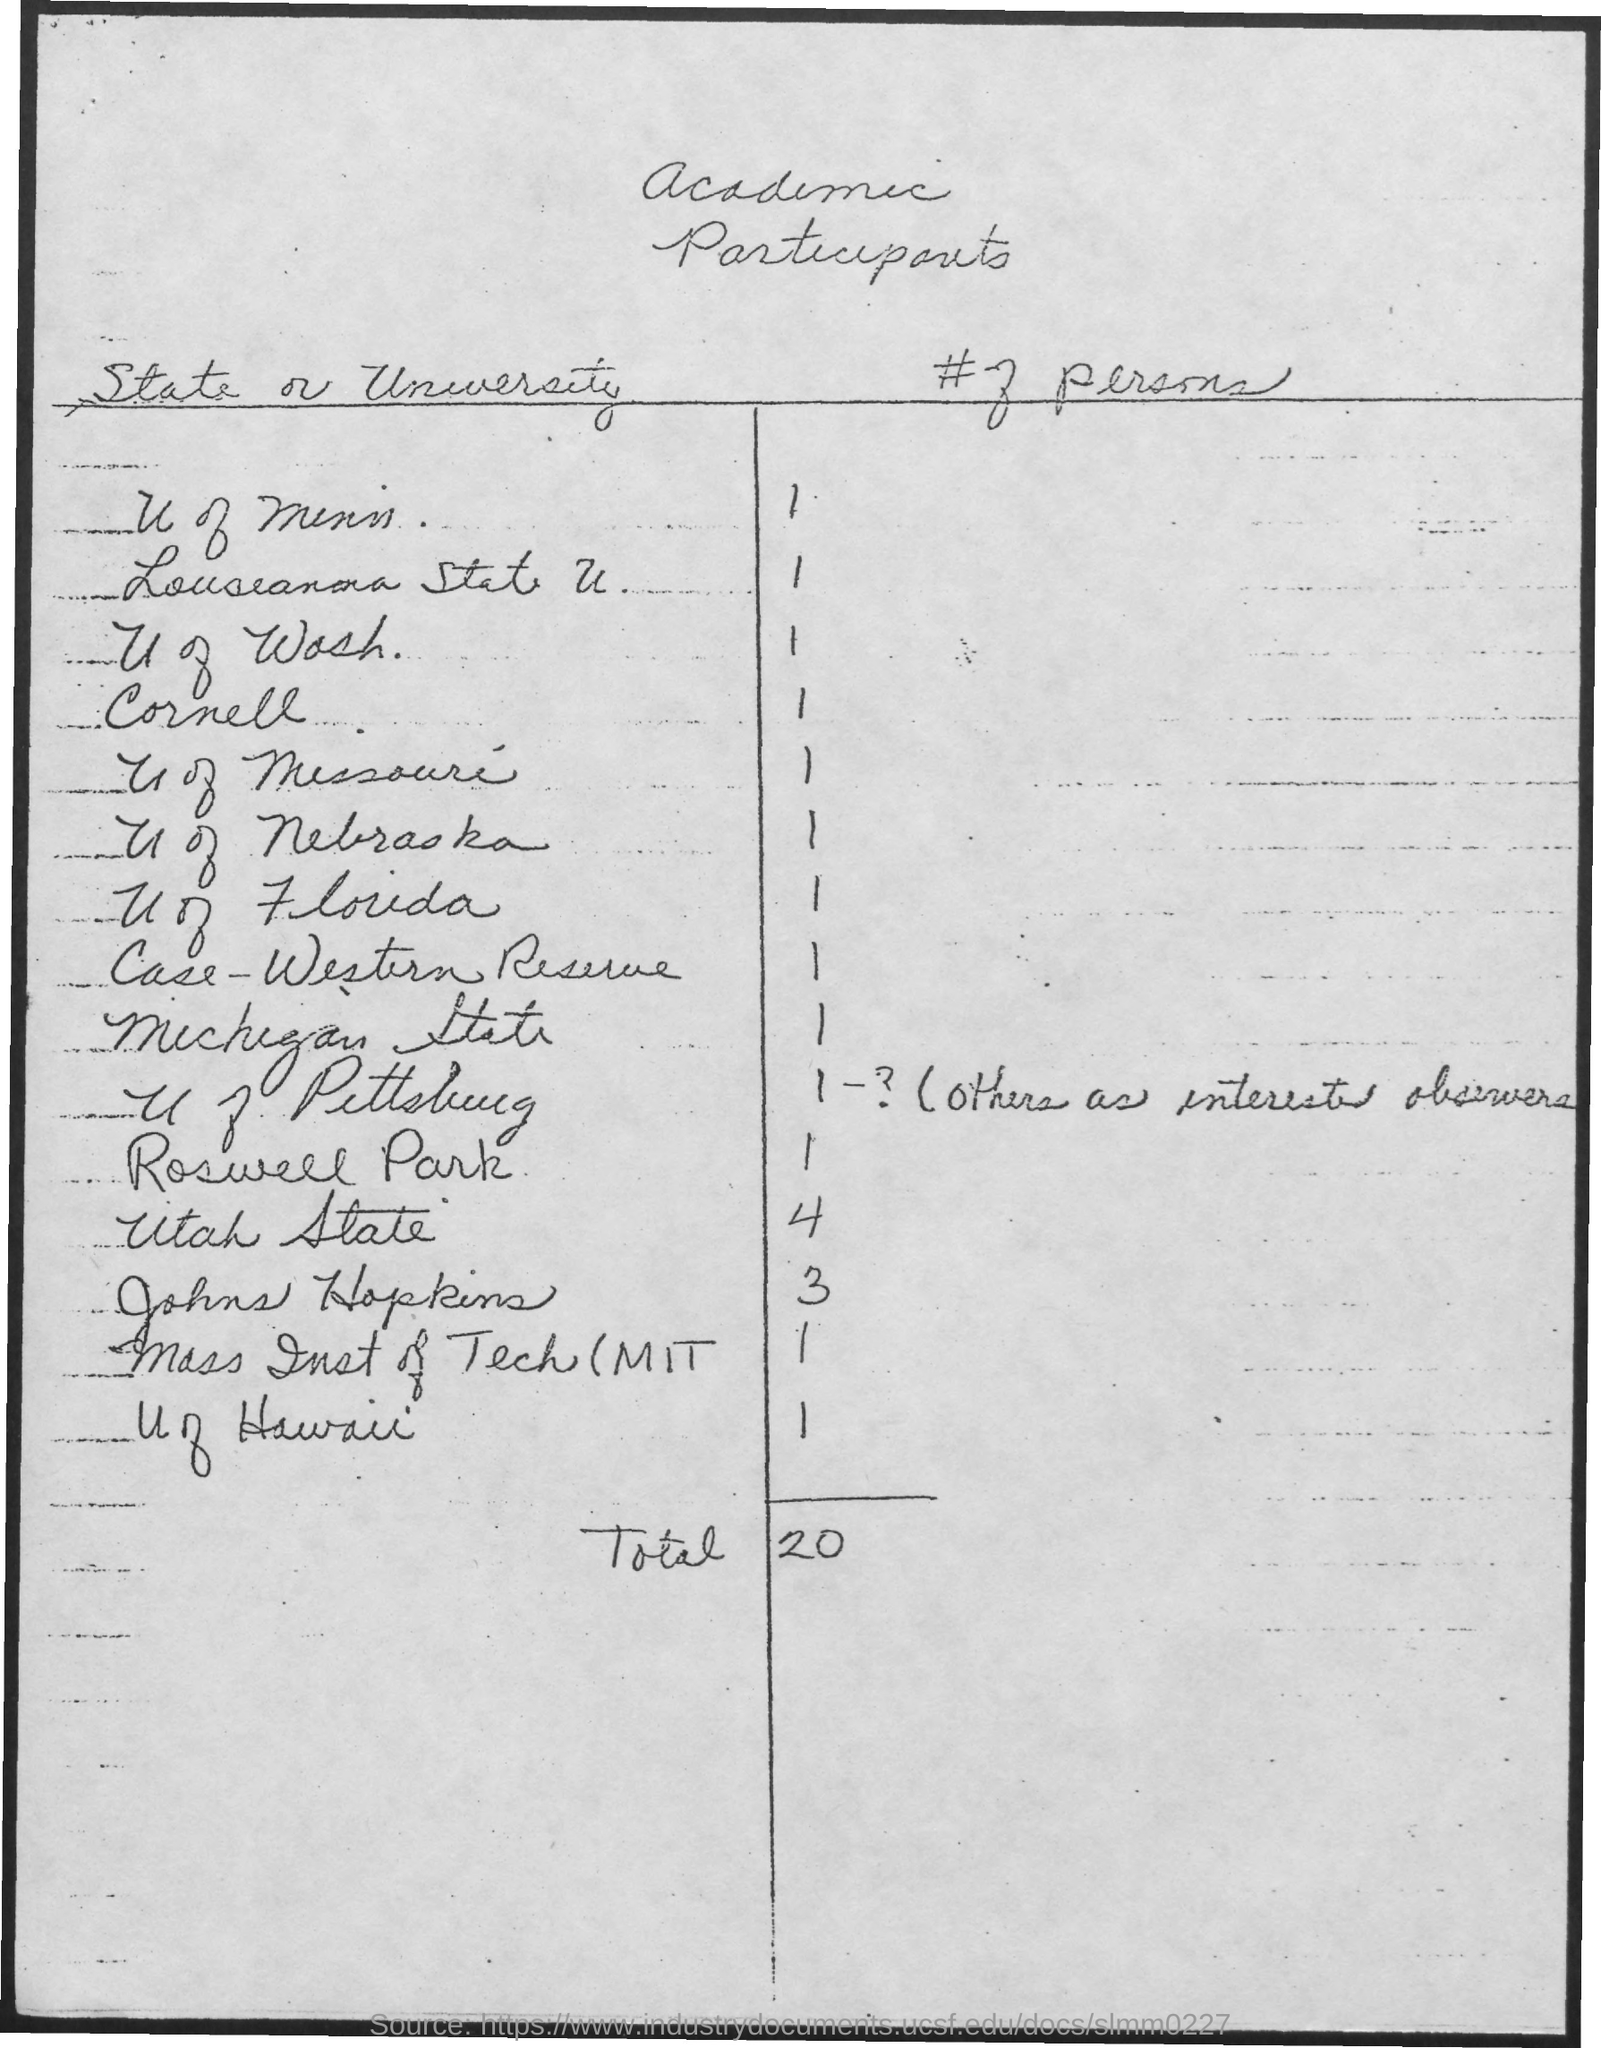Which state or university has 4 participants?
Provide a short and direct response. Utah State. What is the total number of participants?
Provide a succinct answer. 20. 